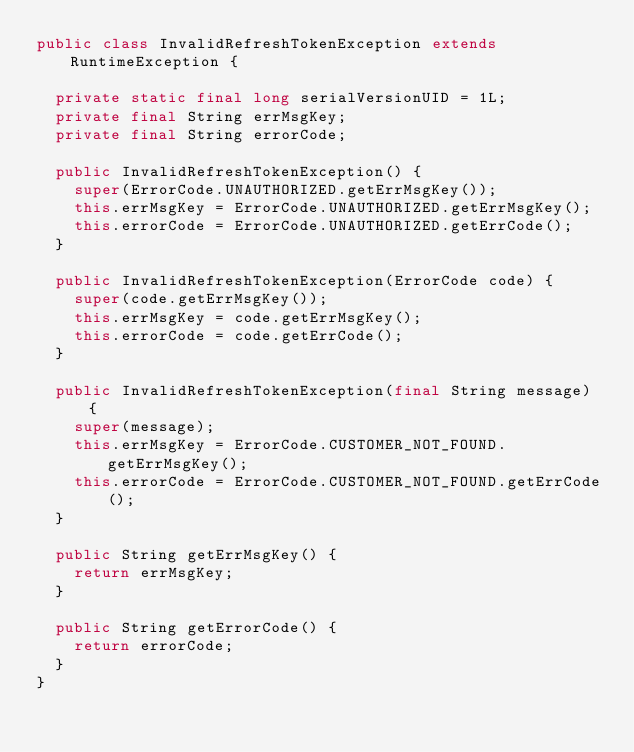Convert code to text. <code><loc_0><loc_0><loc_500><loc_500><_Java_>public class InvalidRefreshTokenException extends RuntimeException {

  private static final long serialVersionUID = 1L;
  private final String errMsgKey;
  private final String errorCode;

  public InvalidRefreshTokenException() {
    super(ErrorCode.UNAUTHORIZED.getErrMsgKey());
    this.errMsgKey = ErrorCode.UNAUTHORIZED.getErrMsgKey();
    this.errorCode = ErrorCode.UNAUTHORIZED.getErrCode();
  }

  public InvalidRefreshTokenException(ErrorCode code) {
    super(code.getErrMsgKey());
    this.errMsgKey = code.getErrMsgKey();
    this.errorCode = code.getErrCode();
  }

  public InvalidRefreshTokenException(final String message) {
    super(message);
    this.errMsgKey = ErrorCode.CUSTOMER_NOT_FOUND.getErrMsgKey();
    this.errorCode = ErrorCode.CUSTOMER_NOT_FOUND.getErrCode();
  }

  public String getErrMsgKey() {
    return errMsgKey;
  }

  public String getErrorCode() {
    return errorCode;
  }
}
</code> 